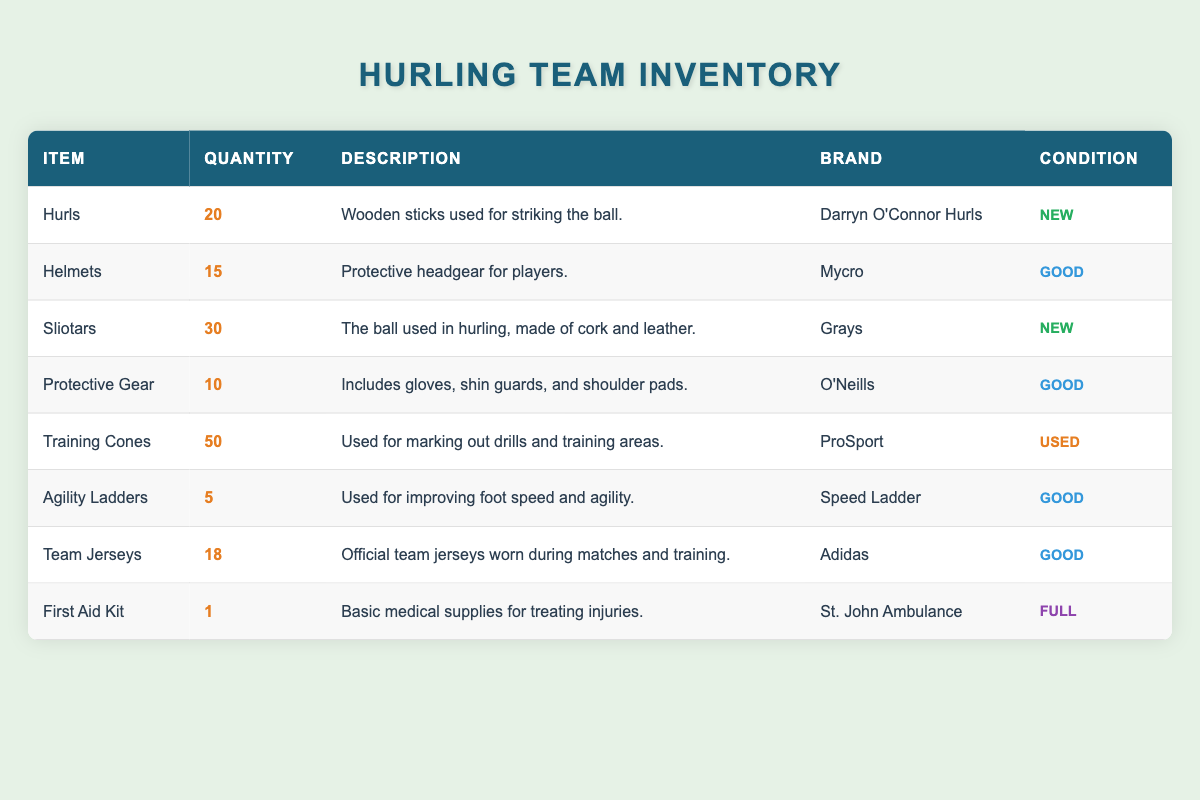What is the total quantity of Sliotars available in the inventory? The inventory lists 30 Sliotars under the item name column with its corresponding quantity. Since there is only one entry for Sliotars, the total quantity is simply 30.
Answer: 30 How many items in the inventory are categorized as "Good"? By examining the table, the items with "Good" condition are Helmets, Protective Gear, Agility Ladders, and Team Jerseys. There are 4 items classified as "Good".
Answer: 4 Is there any item in the inventory that is in "New" condition? The table shows that both Hurls and Sliotars are marked with "New" condition, confirming that there are items classified as "New".
Answer: Yes What is the combined quantity of all types of protective gear (Helmets and Protective Gear)? The quantity of Helmets is 15, and the quantity of Protective Gear is 10. Summing these gives 15 + 10 = 25, making the combined quantity 25.
Answer: 25 Which item has the lowest quantity in the inventory? After reviewing all items, Agility Ladders has the lowest quantity listed at just 5, which is less than all other items.
Answer: Agility Ladders Are there more training cones than team jerseys in inventory? The table indicates there are 50 Training Cones and 18 Team Jerseys. Comparing these amounts shows that 50 is greater than 18, confirming that there are more training cones.
Answer: Yes What percentage of the total inventory items is in "Used" condition? To calculate the percentage, first note that there is only 1 item classified as "Used" (Training Cones) out of a total of 8 items. The percentage is (1/8)*100 = 12.5%.
Answer: 12.5% How many items are there in total within the inventory? By summing the quantities of all listed items (20 + 15 + 30 + 10 + 50 + 5 + 18 + 1), we get a total of 149 items in the inventory.
Answer: 149 What is the brand of the first aid kit, and is it classified as "Full"? The table shows that the First Aid Kit is from the brand "St. John Ambulance" and is clearly marked as "Full" condition, confirming both details.
Answer: Yes, St. John Ambulance 